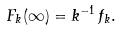Convert formula to latex. <formula><loc_0><loc_0><loc_500><loc_500>F _ { k } ( \infty ) = k ^ { - 1 } \, f _ { k } .</formula> 